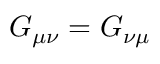Convert formula to latex. <formula><loc_0><loc_0><loc_500><loc_500>G _ { \mu \nu } = G _ { \nu \mu }</formula> 